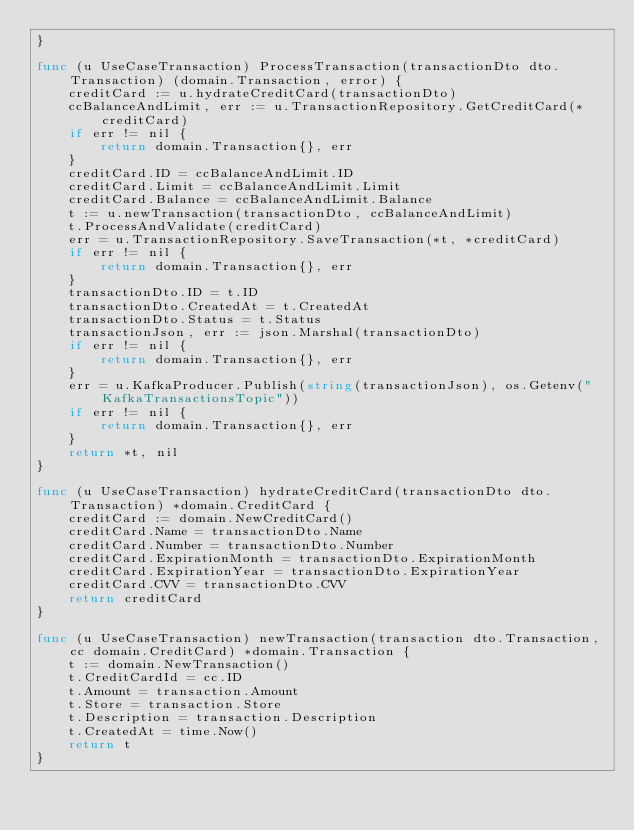<code> <loc_0><loc_0><loc_500><loc_500><_Go_>}

func (u UseCaseTransaction) ProcessTransaction(transactionDto dto.Transaction) (domain.Transaction, error) {
	creditCard := u.hydrateCreditCard(transactionDto)
	ccBalanceAndLimit, err := u.TransactionRepository.GetCreditCard(*creditCard)
	if err != nil {
		return domain.Transaction{}, err
	}
	creditCard.ID = ccBalanceAndLimit.ID
	creditCard.Limit = ccBalanceAndLimit.Limit
	creditCard.Balance = ccBalanceAndLimit.Balance
	t := u.newTransaction(transactionDto, ccBalanceAndLimit)
	t.ProcessAndValidate(creditCard)
	err = u.TransactionRepository.SaveTransaction(*t, *creditCard)
	if err != nil {
		return domain.Transaction{}, err
	}
	transactionDto.ID = t.ID
	transactionDto.CreatedAt = t.CreatedAt
	transactionDto.Status = t.Status
	transactionJson, err := json.Marshal(transactionDto)
	if err != nil {
		return domain.Transaction{}, err
	}
	err = u.KafkaProducer.Publish(string(transactionJson), os.Getenv("KafkaTransactionsTopic"))
	if err != nil {
		return domain.Transaction{}, err
	}
	return *t, nil
}

func (u UseCaseTransaction) hydrateCreditCard(transactionDto dto.Transaction) *domain.CreditCard {
	creditCard := domain.NewCreditCard()
	creditCard.Name = transactionDto.Name
	creditCard.Number = transactionDto.Number
	creditCard.ExpirationMonth = transactionDto.ExpirationMonth
	creditCard.ExpirationYear = transactionDto.ExpirationYear
	creditCard.CVV = transactionDto.CVV
	return creditCard
}

func (u UseCaseTransaction) newTransaction(transaction dto.Transaction, cc domain.CreditCard) *domain.Transaction {
	t := domain.NewTransaction()
	t.CreditCardId = cc.ID
	t.Amount = transaction.Amount
	t.Store = transaction.Store
	t.Description = transaction.Description
	t.CreatedAt = time.Now()
	return t
}
</code> 